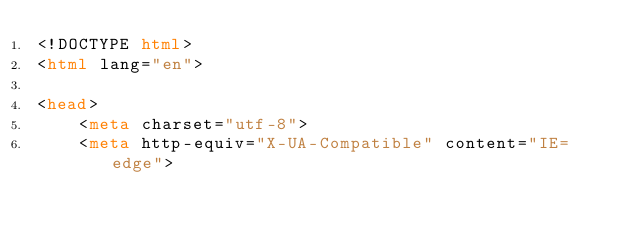Convert code to text. <code><loc_0><loc_0><loc_500><loc_500><_HTML_><!DOCTYPE html>
<html lang="en">

<head>
    <meta charset="utf-8">
    <meta http-equiv="X-UA-Compatible" content="IE=edge"></code> 